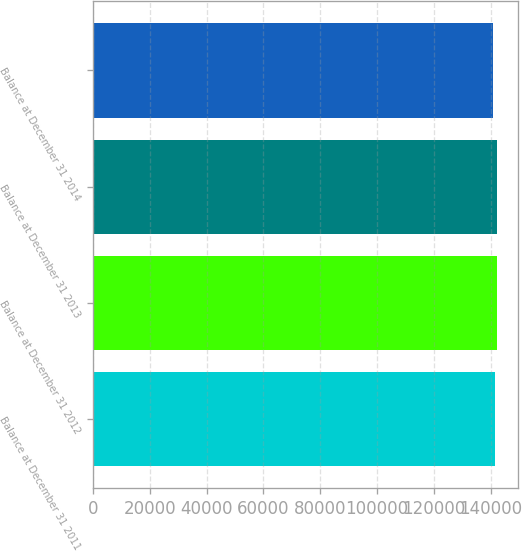Convert chart. <chart><loc_0><loc_0><loc_500><loc_500><bar_chart><fcel>Balance at December 31 2011<fcel>Balance at December 31 2012<fcel>Balance at December 31 2013<fcel>Balance at December 31 2014<nl><fcel>141632<fcel>142389<fcel>142241<fcel>140844<nl></chart> 